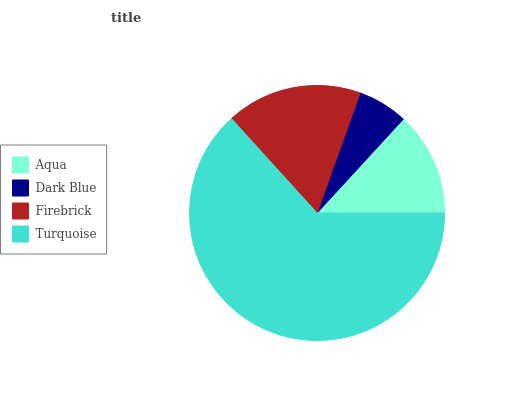Is Dark Blue the minimum?
Answer yes or no. Yes. Is Turquoise the maximum?
Answer yes or no. Yes. Is Firebrick the minimum?
Answer yes or no. No. Is Firebrick the maximum?
Answer yes or no. No. Is Firebrick greater than Dark Blue?
Answer yes or no. Yes. Is Dark Blue less than Firebrick?
Answer yes or no. Yes. Is Dark Blue greater than Firebrick?
Answer yes or no. No. Is Firebrick less than Dark Blue?
Answer yes or no. No. Is Firebrick the high median?
Answer yes or no. Yes. Is Aqua the low median?
Answer yes or no. Yes. Is Aqua the high median?
Answer yes or no. No. Is Firebrick the low median?
Answer yes or no. No. 